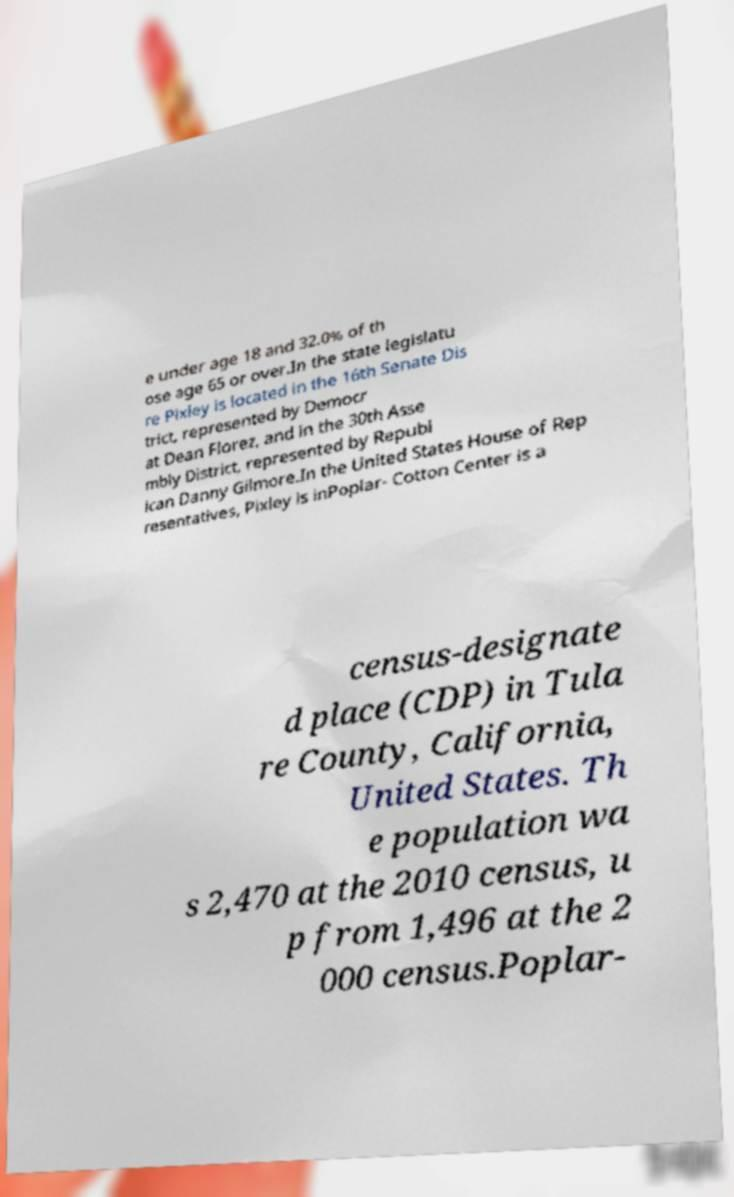Could you extract and type out the text from this image? e under age 18 and 32.0% of th ose age 65 or over.In the state legislatu re Pixley is located in the 16th Senate Dis trict, represented by Democr at Dean Florez, and in the 30th Asse mbly District, represented by Republ ican Danny Gilmore.In the United States House of Rep resentatives, Pixley is inPoplar- Cotton Center is a census-designate d place (CDP) in Tula re County, California, United States. Th e population wa s 2,470 at the 2010 census, u p from 1,496 at the 2 000 census.Poplar- 